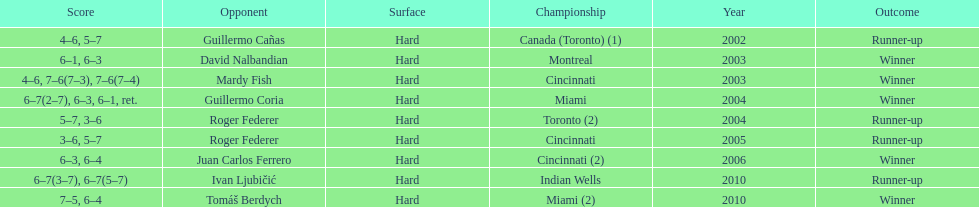What was the highest number of consecutive wins? 3. 